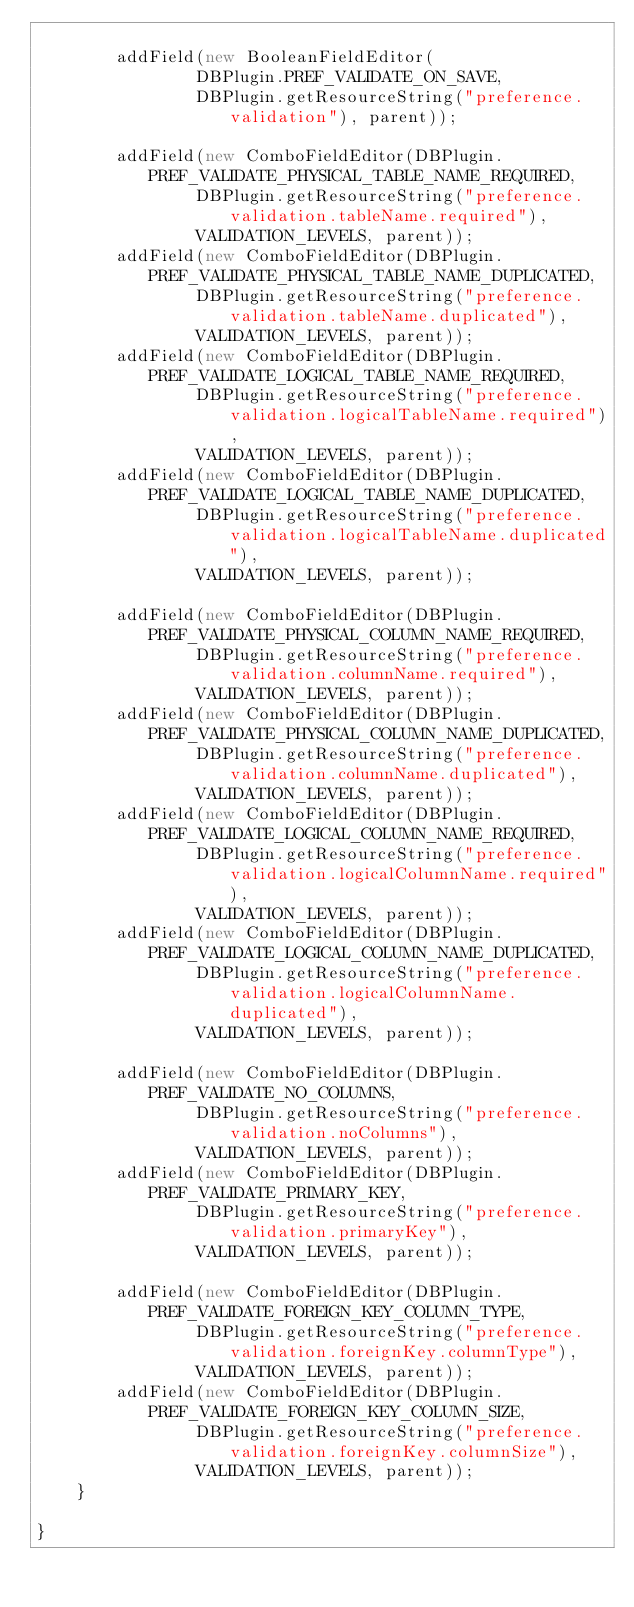<code> <loc_0><loc_0><loc_500><loc_500><_Java_>        
        addField(new BooleanFieldEditor(
                DBPlugin.PREF_VALIDATE_ON_SAVE,
                DBPlugin.getResourceString("preference.validation"), parent));
        
        addField(new ComboFieldEditor(DBPlugin.PREF_VALIDATE_PHYSICAL_TABLE_NAME_REQUIRED,
                DBPlugin.getResourceString("preference.validation.tableName.required"), 
                VALIDATION_LEVELS, parent));
        addField(new ComboFieldEditor(DBPlugin.PREF_VALIDATE_PHYSICAL_TABLE_NAME_DUPLICATED,
                DBPlugin.getResourceString("preference.validation.tableName.duplicated"), 
                VALIDATION_LEVELS, parent));
        addField(new ComboFieldEditor(DBPlugin.PREF_VALIDATE_LOGICAL_TABLE_NAME_REQUIRED,
                DBPlugin.getResourceString("preference.validation.logicalTableName.required"), 
                VALIDATION_LEVELS, parent));
        addField(new ComboFieldEditor(DBPlugin.PREF_VALIDATE_LOGICAL_TABLE_NAME_DUPLICATED,
                DBPlugin.getResourceString("preference.validation.logicalTableName.duplicated"), 
                VALIDATION_LEVELS, parent));
        
        addField(new ComboFieldEditor(DBPlugin.PREF_VALIDATE_PHYSICAL_COLUMN_NAME_REQUIRED,
                DBPlugin.getResourceString("preference.validation.columnName.required"), 
                VALIDATION_LEVELS, parent));
        addField(new ComboFieldEditor(DBPlugin.PREF_VALIDATE_PHYSICAL_COLUMN_NAME_DUPLICATED,
                DBPlugin.getResourceString("preference.validation.columnName.duplicated"), 
                VALIDATION_LEVELS, parent));
        addField(new ComboFieldEditor(DBPlugin.PREF_VALIDATE_LOGICAL_COLUMN_NAME_REQUIRED,
                DBPlugin.getResourceString("preference.validation.logicalColumnName.required"), 
                VALIDATION_LEVELS, parent));
        addField(new ComboFieldEditor(DBPlugin.PREF_VALIDATE_LOGICAL_COLUMN_NAME_DUPLICATED,
                DBPlugin.getResourceString("preference.validation.logicalColumnName.duplicated"), 
                VALIDATION_LEVELS, parent));
        
        addField(new ComboFieldEditor(DBPlugin.PREF_VALIDATE_NO_COLUMNS,
                DBPlugin.getResourceString("preference.validation.noColumns"), 
                VALIDATION_LEVELS, parent));
        addField(new ComboFieldEditor(DBPlugin.PREF_VALIDATE_PRIMARY_KEY,
                DBPlugin.getResourceString("preference.validation.primaryKey"), 
                VALIDATION_LEVELS, parent));
        
        addField(new ComboFieldEditor(DBPlugin.PREF_VALIDATE_FOREIGN_KEY_COLUMN_TYPE,
                DBPlugin.getResourceString("preference.validation.foreignKey.columnType"), 
                VALIDATION_LEVELS, parent));
        addField(new ComboFieldEditor(DBPlugin.PREF_VALIDATE_FOREIGN_KEY_COLUMN_SIZE,
                DBPlugin.getResourceString("preference.validation.foreignKey.columnSize"), 
                VALIDATION_LEVELS, parent));
    }
    
}
</code> 